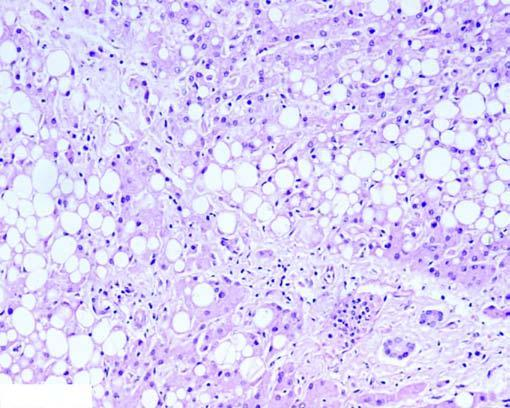re the centres of whorls of smooth muscle and connective tissue distended with large fat vacuoles pushing the nuclei to the periphery (macrovesicles), while others show multiple small vacuoles in the cytoplasm (microvesicles)?
Answer the question using a single word or phrase. No 